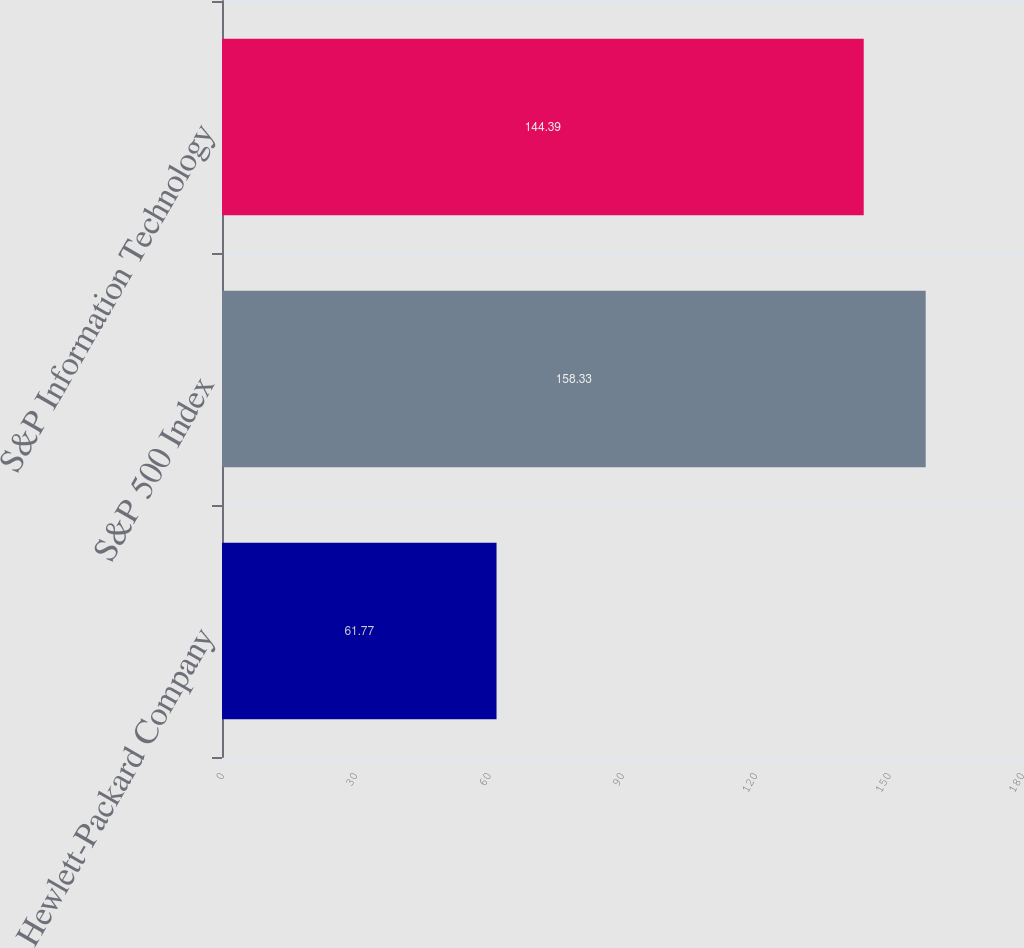Convert chart to OTSL. <chart><loc_0><loc_0><loc_500><loc_500><bar_chart><fcel>Hewlett-Packard Company<fcel>S&P 500 Index<fcel>S&P Information Technology<nl><fcel>61.77<fcel>158.33<fcel>144.39<nl></chart> 